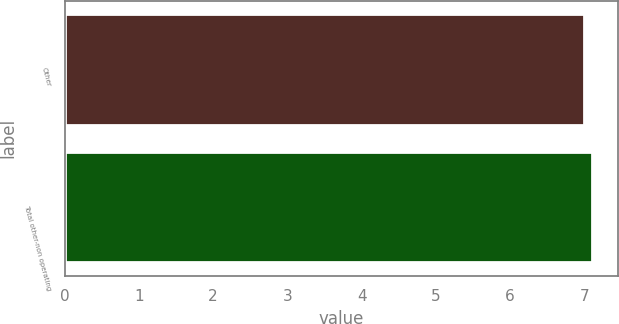<chart> <loc_0><loc_0><loc_500><loc_500><bar_chart><fcel>Other<fcel>Total other-non operating<nl><fcel>7<fcel>7.1<nl></chart> 